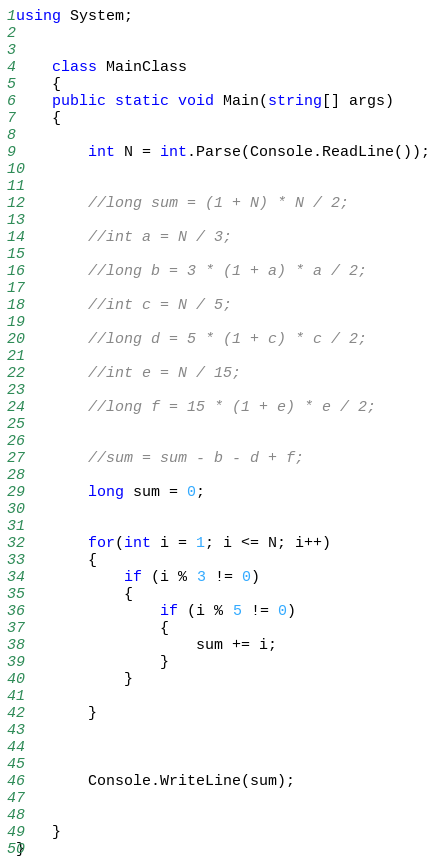<code> <loc_0><loc_0><loc_500><loc_500><_C#_>using System;


    class MainClass
    {
    public static void Main(string[] args)
    {

        int N = int.Parse(Console.ReadLine());


        //long sum = (1 + N) * N / 2;

        //int a = N / 3;

        //long b = 3 * (1 + a) * a / 2;

        //int c = N / 5;

        //long d = 5 * (1 + c) * c / 2;

        //int e = N / 15;

        //long f = 15 * (1 + e) * e / 2;


        //sum = sum - b - d + f;

        long sum = 0;


        for(int i = 1; i <= N; i++)
        {
            if (i % 3 != 0)
            {
                if (i % 5 != 0)
                {
                    sum += i;
                }
            }

        }



        Console.WriteLine(sum);


    }
}
</code> 